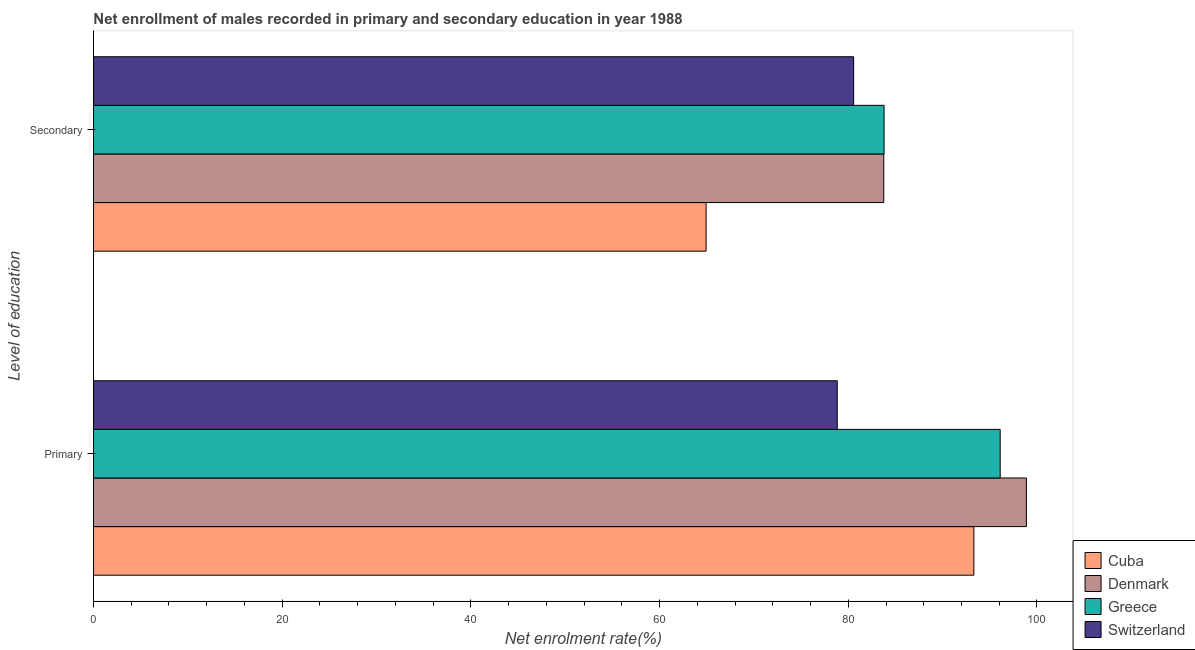How many different coloured bars are there?
Keep it short and to the point. 4. How many bars are there on the 2nd tick from the top?
Your response must be concise. 4. How many bars are there on the 1st tick from the bottom?
Offer a very short reply. 4. What is the label of the 2nd group of bars from the top?
Your answer should be compact. Primary. What is the enrollment rate in secondary education in Greece?
Offer a very short reply. 83.8. Across all countries, what is the maximum enrollment rate in secondary education?
Offer a very short reply. 83.8. Across all countries, what is the minimum enrollment rate in secondary education?
Give a very brief answer. 64.93. In which country was the enrollment rate in primary education maximum?
Your answer should be compact. Denmark. In which country was the enrollment rate in secondary education minimum?
Provide a succinct answer. Cuba. What is the total enrollment rate in secondary education in the graph?
Provide a succinct answer. 313.07. What is the difference between the enrollment rate in secondary education in Denmark and that in Greece?
Offer a terse response. -0.03. What is the difference between the enrollment rate in secondary education in Cuba and the enrollment rate in primary education in Switzerland?
Your answer should be compact. -13.9. What is the average enrollment rate in secondary education per country?
Make the answer very short. 78.27. What is the difference between the enrollment rate in secondary education and enrollment rate in primary education in Greece?
Your answer should be very brief. -12.31. What is the ratio of the enrollment rate in secondary education in Denmark to that in Switzerland?
Provide a short and direct response. 1.04. What does the 1st bar from the bottom in Primary represents?
Your answer should be very brief. Cuba. What is the difference between two consecutive major ticks on the X-axis?
Your answer should be compact. 20. Where does the legend appear in the graph?
Give a very brief answer. Bottom right. How many legend labels are there?
Your answer should be compact. 4. How are the legend labels stacked?
Give a very brief answer. Vertical. What is the title of the graph?
Offer a very short reply. Net enrollment of males recorded in primary and secondary education in year 1988. What is the label or title of the X-axis?
Make the answer very short. Net enrolment rate(%). What is the label or title of the Y-axis?
Provide a succinct answer. Level of education. What is the Net enrolment rate(%) in Cuba in Primary?
Provide a succinct answer. 93.31. What is the Net enrolment rate(%) in Denmark in Primary?
Ensure brevity in your answer.  98.88. What is the Net enrolment rate(%) of Greece in Primary?
Provide a short and direct response. 96.1. What is the Net enrolment rate(%) in Switzerland in Primary?
Make the answer very short. 78.84. What is the Net enrolment rate(%) of Cuba in Secondary?
Provide a short and direct response. 64.93. What is the Net enrolment rate(%) in Denmark in Secondary?
Ensure brevity in your answer.  83.77. What is the Net enrolment rate(%) in Greece in Secondary?
Your answer should be very brief. 83.8. What is the Net enrolment rate(%) of Switzerland in Secondary?
Your answer should be compact. 80.57. Across all Level of education, what is the maximum Net enrolment rate(%) of Cuba?
Keep it short and to the point. 93.31. Across all Level of education, what is the maximum Net enrolment rate(%) of Denmark?
Ensure brevity in your answer.  98.88. Across all Level of education, what is the maximum Net enrolment rate(%) in Greece?
Provide a short and direct response. 96.1. Across all Level of education, what is the maximum Net enrolment rate(%) in Switzerland?
Offer a very short reply. 80.57. Across all Level of education, what is the minimum Net enrolment rate(%) of Cuba?
Give a very brief answer. 64.93. Across all Level of education, what is the minimum Net enrolment rate(%) of Denmark?
Provide a short and direct response. 83.77. Across all Level of education, what is the minimum Net enrolment rate(%) of Greece?
Provide a succinct answer. 83.8. Across all Level of education, what is the minimum Net enrolment rate(%) of Switzerland?
Keep it short and to the point. 78.84. What is the total Net enrolment rate(%) of Cuba in the graph?
Your answer should be compact. 158.24. What is the total Net enrolment rate(%) of Denmark in the graph?
Your answer should be compact. 182.65. What is the total Net enrolment rate(%) in Greece in the graph?
Give a very brief answer. 179.9. What is the total Net enrolment rate(%) in Switzerland in the graph?
Your response must be concise. 159.41. What is the difference between the Net enrolment rate(%) in Cuba in Primary and that in Secondary?
Your answer should be very brief. 28.38. What is the difference between the Net enrolment rate(%) of Denmark in Primary and that in Secondary?
Your response must be concise. 15.12. What is the difference between the Net enrolment rate(%) in Greece in Primary and that in Secondary?
Offer a very short reply. 12.31. What is the difference between the Net enrolment rate(%) of Switzerland in Primary and that in Secondary?
Your response must be concise. -1.74. What is the difference between the Net enrolment rate(%) of Cuba in Primary and the Net enrolment rate(%) of Denmark in Secondary?
Provide a short and direct response. 9.55. What is the difference between the Net enrolment rate(%) in Cuba in Primary and the Net enrolment rate(%) in Greece in Secondary?
Your response must be concise. 9.52. What is the difference between the Net enrolment rate(%) of Cuba in Primary and the Net enrolment rate(%) of Switzerland in Secondary?
Keep it short and to the point. 12.74. What is the difference between the Net enrolment rate(%) in Denmark in Primary and the Net enrolment rate(%) in Greece in Secondary?
Provide a short and direct response. 15.08. What is the difference between the Net enrolment rate(%) in Denmark in Primary and the Net enrolment rate(%) in Switzerland in Secondary?
Provide a succinct answer. 18.31. What is the difference between the Net enrolment rate(%) in Greece in Primary and the Net enrolment rate(%) in Switzerland in Secondary?
Offer a very short reply. 15.53. What is the average Net enrolment rate(%) of Cuba per Level of education?
Your answer should be very brief. 79.12. What is the average Net enrolment rate(%) in Denmark per Level of education?
Ensure brevity in your answer.  91.32. What is the average Net enrolment rate(%) in Greece per Level of education?
Make the answer very short. 89.95. What is the average Net enrolment rate(%) of Switzerland per Level of education?
Ensure brevity in your answer.  79.7. What is the difference between the Net enrolment rate(%) in Cuba and Net enrolment rate(%) in Denmark in Primary?
Provide a succinct answer. -5.57. What is the difference between the Net enrolment rate(%) in Cuba and Net enrolment rate(%) in Greece in Primary?
Ensure brevity in your answer.  -2.79. What is the difference between the Net enrolment rate(%) in Cuba and Net enrolment rate(%) in Switzerland in Primary?
Provide a succinct answer. 14.48. What is the difference between the Net enrolment rate(%) of Denmark and Net enrolment rate(%) of Greece in Primary?
Ensure brevity in your answer.  2.78. What is the difference between the Net enrolment rate(%) in Denmark and Net enrolment rate(%) in Switzerland in Primary?
Offer a very short reply. 20.05. What is the difference between the Net enrolment rate(%) in Greece and Net enrolment rate(%) in Switzerland in Primary?
Your response must be concise. 17.27. What is the difference between the Net enrolment rate(%) in Cuba and Net enrolment rate(%) in Denmark in Secondary?
Your answer should be compact. -18.83. What is the difference between the Net enrolment rate(%) of Cuba and Net enrolment rate(%) of Greece in Secondary?
Provide a short and direct response. -18.86. What is the difference between the Net enrolment rate(%) in Cuba and Net enrolment rate(%) in Switzerland in Secondary?
Keep it short and to the point. -15.64. What is the difference between the Net enrolment rate(%) in Denmark and Net enrolment rate(%) in Greece in Secondary?
Give a very brief answer. -0.03. What is the difference between the Net enrolment rate(%) in Denmark and Net enrolment rate(%) in Switzerland in Secondary?
Keep it short and to the point. 3.19. What is the difference between the Net enrolment rate(%) of Greece and Net enrolment rate(%) of Switzerland in Secondary?
Offer a very short reply. 3.23. What is the ratio of the Net enrolment rate(%) of Cuba in Primary to that in Secondary?
Provide a short and direct response. 1.44. What is the ratio of the Net enrolment rate(%) of Denmark in Primary to that in Secondary?
Offer a very short reply. 1.18. What is the ratio of the Net enrolment rate(%) of Greece in Primary to that in Secondary?
Provide a succinct answer. 1.15. What is the ratio of the Net enrolment rate(%) of Switzerland in Primary to that in Secondary?
Offer a terse response. 0.98. What is the difference between the highest and the second highest Net enrolment rate(%) in Cuba?
Offer a terse response. 28.38. What is the difference between the highest and the second highest Net enrolment rate(%) of Denmark?
Offer a very short reply. 15.12. What is the difference between the highest and the second highest Net enrolment rate(%) in Greece?
Offer a very short reply. 12.31. What is the difference between the highest and the second highest Net enrolment rate(%) in Switzerland?
Offer a very short reply. 1.74. What is the difference between the highest and the lowest Net enrolment rate(%) in Cuba?
Make the answer very short. 28.38. What is the difference between the highest and the lowest Net enrolment rate(%) of Denmark?
Make the answer very short. 15.12. What is the difference between the highest and the lowest Net enrolment rate(%) of Greece?
Offer a very short reply. 12.31. What is the difference between the highest and the lowest Net enrolment rate(%) in Switzerland?
Keep it short and to the point. 1.74. 